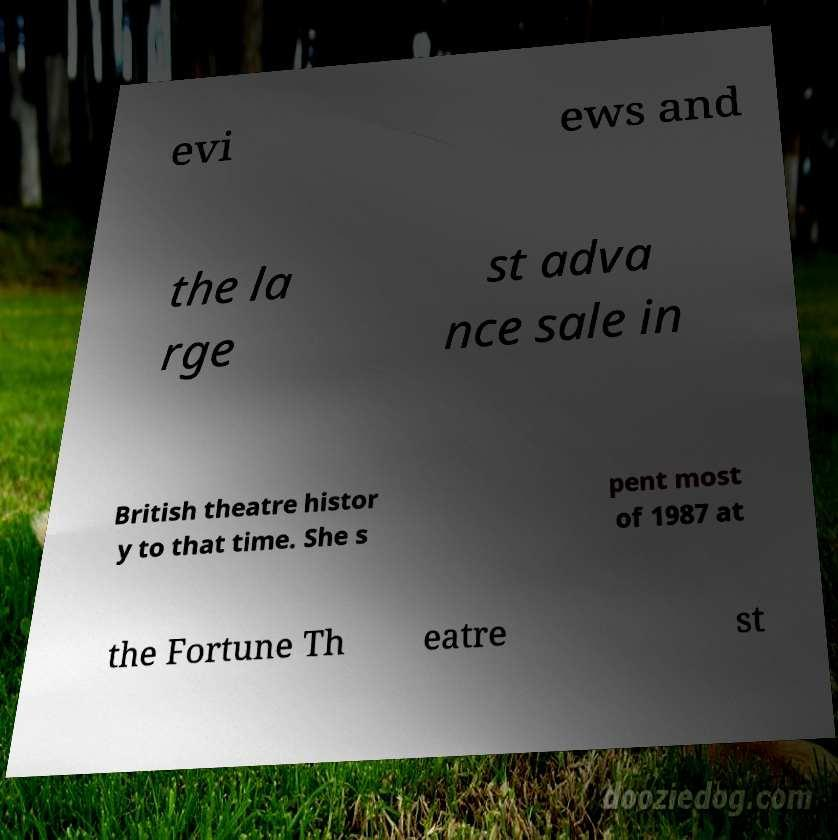Could you extract and type out the text from this image? evi ews and the la rge st adva nce sale in British theatre histor y to that time. She s pent most of 1987 at the Fortune Th eatre st 